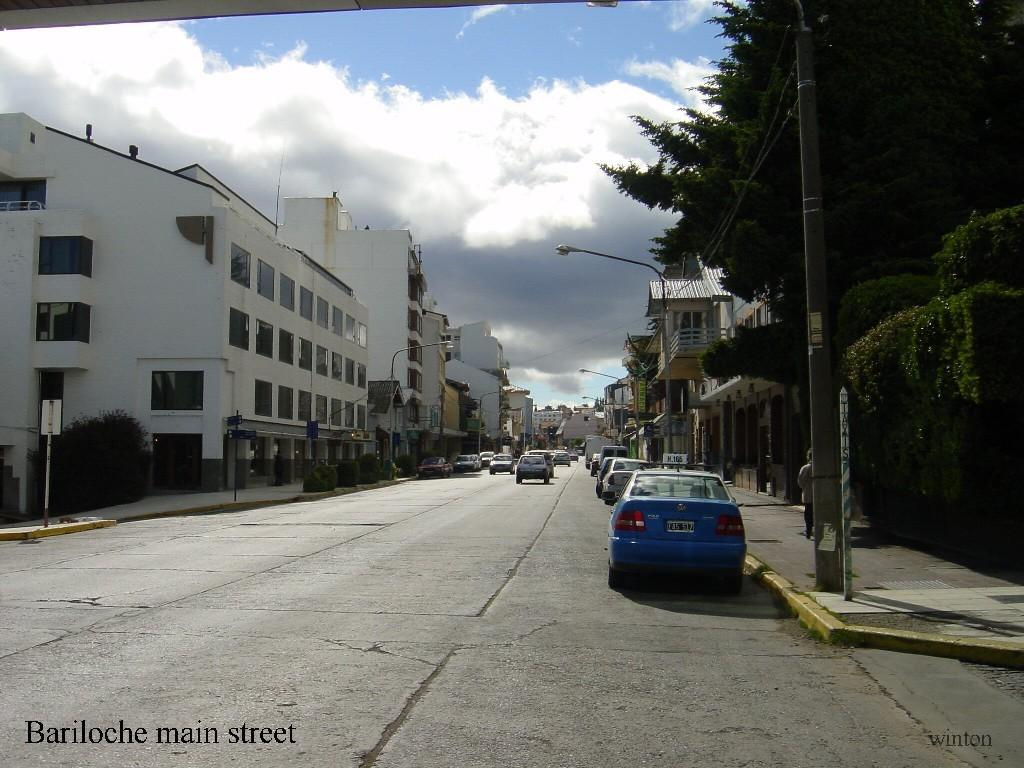What can be seen on the road in the image? There are vehicles on the road in the image. What is located on the left side of the image? There is text on the left side of the image. What type of lighting is present along the road in the image? Street lights are visible in the image. What can be seen in the background of the image? Trees and buildings are visible in the background of the image. What is the color of the sky in the image? The sky is blue in color. What type of coat is the rule wearing in the image? There is no rule or coat present in the image; it features vehicles on the road, text, street lights, trees, buildings, and a blue sky. What is the learning process for the trees in the image? There is no learning process for the trees in the image; they are simply part of the background vegetation. 